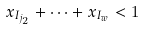Convert formula to latex. <formula><loc_0><loc_0><loc_500><loc_500>x _ { I _ { j _ { 2 } } } + \cdots + x _ { I _ { w } } < 1</formula> 